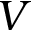Convert formula to latex. <formula><loc_0><loc_0><loc_500><loc_500>V</formula> 